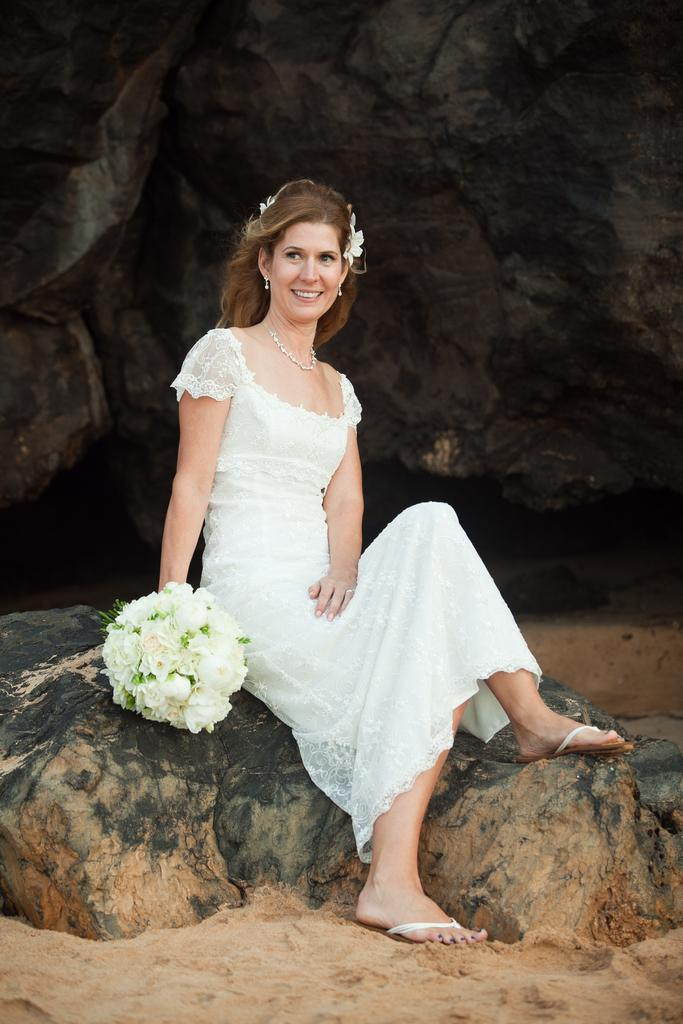Who is the main subject in the image? There is a woman in the image. What is the woman wearing? The woman is wearing a white dress. What is the woman holding in the image? The woman is holding a bouquet. What is the woman's posture in the image? The woman is sitting. What can be seen behind the woman in the image? There is a rock behind the woman. What type of polish is the woman applying to her nails in the image? There is no indication in the image that the woman is applying polish to her nails, as she is holding a bouquet and not shown with any nail polish or tools. 